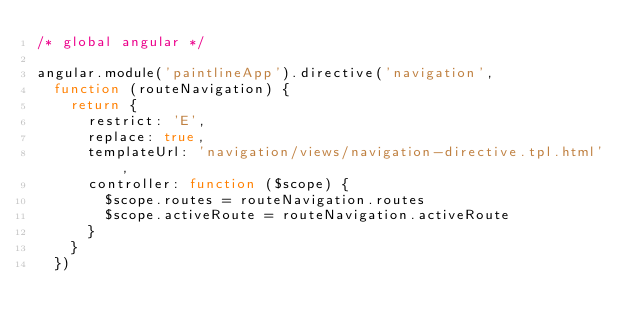Convert code to text. <code><loc_0><loc_0><loc_500><loc_500><_JavaScript_>/* global angular */

angular.module('paintlineApp').directive('navigation',
  function (routeNavigation) {
    return {
      restrict: 'E',
      replace: true,
      templateUrl: 'navigation/views/navigation-directive.tpl.html',
      controller: function ($scope) {
        $scope.routes = routeNavigation.routes
        $scope.activeRoute = routeNavigation.activeRoute
      }
    }
  })
</code> 